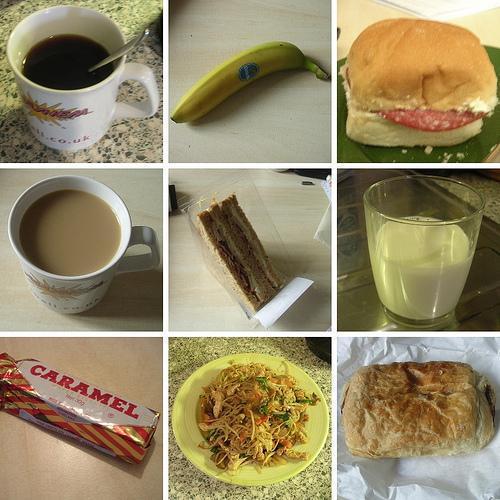How many drinks are pictured?
Give a very brief answer. 3. How many bananas are in the photos?
Give a very brief answer. 1. How many beverages are there in this group of pictures?
Give a very brief answer. 3. How many sandwiches are in the picture?
Give a very brief answer. 3. How many cups are in the photo?
Give a very brief answer. 3. How many people are not wearing glasses?
Give a very brief answer. 0. 